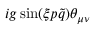<formula> <loc_0><loc_0><loc_500><loc_500>i g \sin ( \xi p \tilde { q } ) \theta _ { \mu \nu }</formula> 